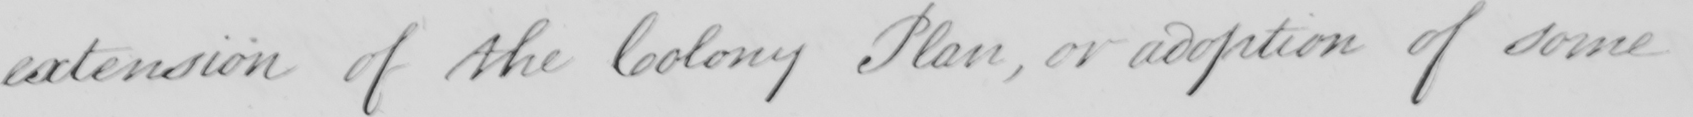Transcribe the text shown in this historical manuscript line. extension of the Colony Plan, or adoption of some 